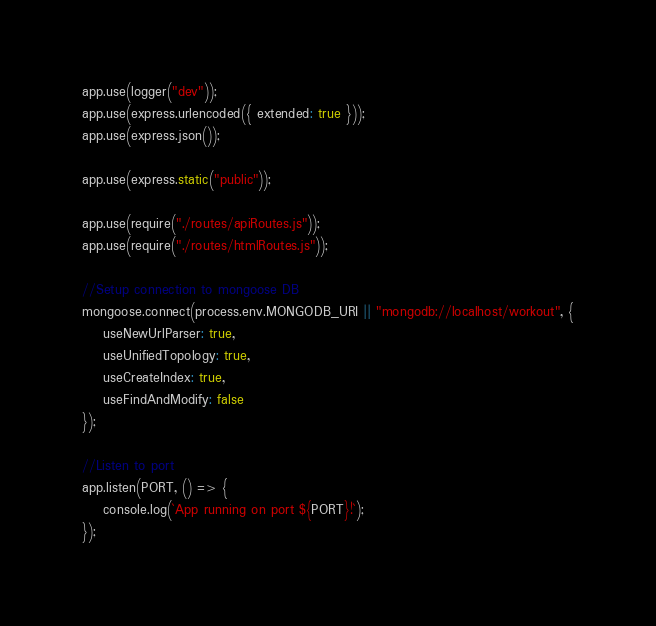<code> <loc_0><loc_0><loc_500><loc_500><_JavaScript_>
app.use(logger("dev"));
app.use(express.urlencoded({ extended: true }));
app.use(express.json());

app.use(express.static("public"));

app.use(require("./routes/apiRoutes.js"));
app.use(require("./routes/htmlRoutes.js"));

//Setup connection to mongoose DB
mongoose.connect(process.env.MONGODB_URI || "mongodb://localhost/workout", {
    useNewUrlParser: true,
    useUnifiedTopology: true,
    useCreateIndex: true,
    useFindAndModify: false
});

//Listen to port
app.listen(PORT, () => {
    console.log(`App running on port ${PORT}!`);
});
</code> 